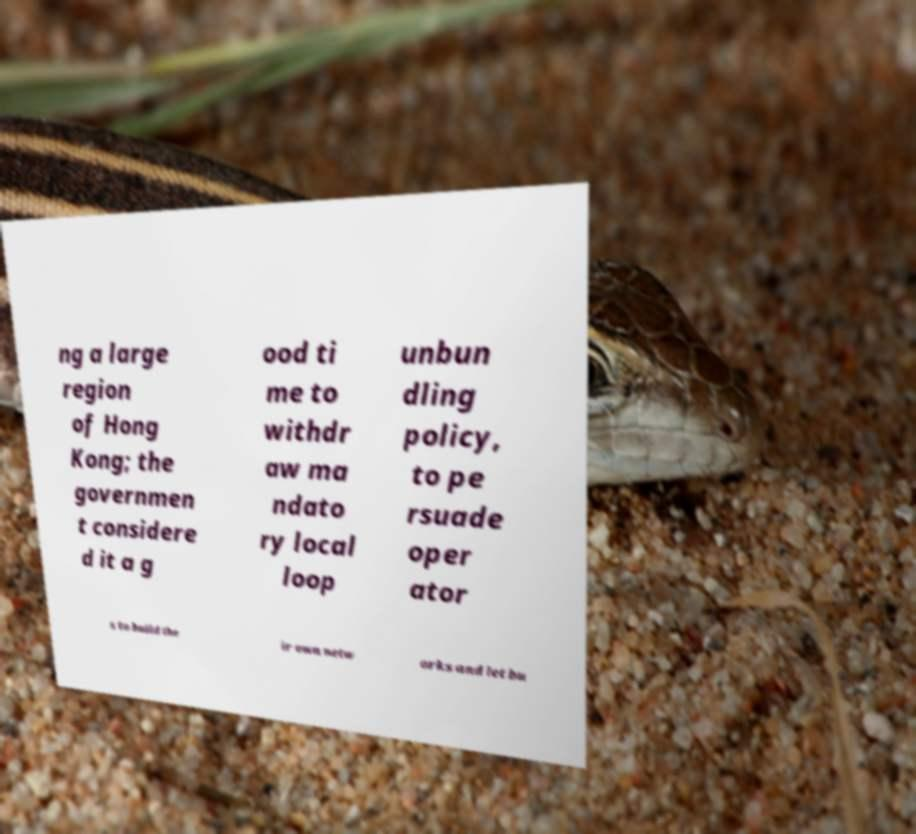Can you accurately transcribe the text from the provided image for me? ng a large region of Hong Kong; the governmen t considere d it a g ood ti me to withdr aw ma ndato ry local loop unbun dling policy, to pe rsuade oper ator s to build the ir own netw orks and let bu 